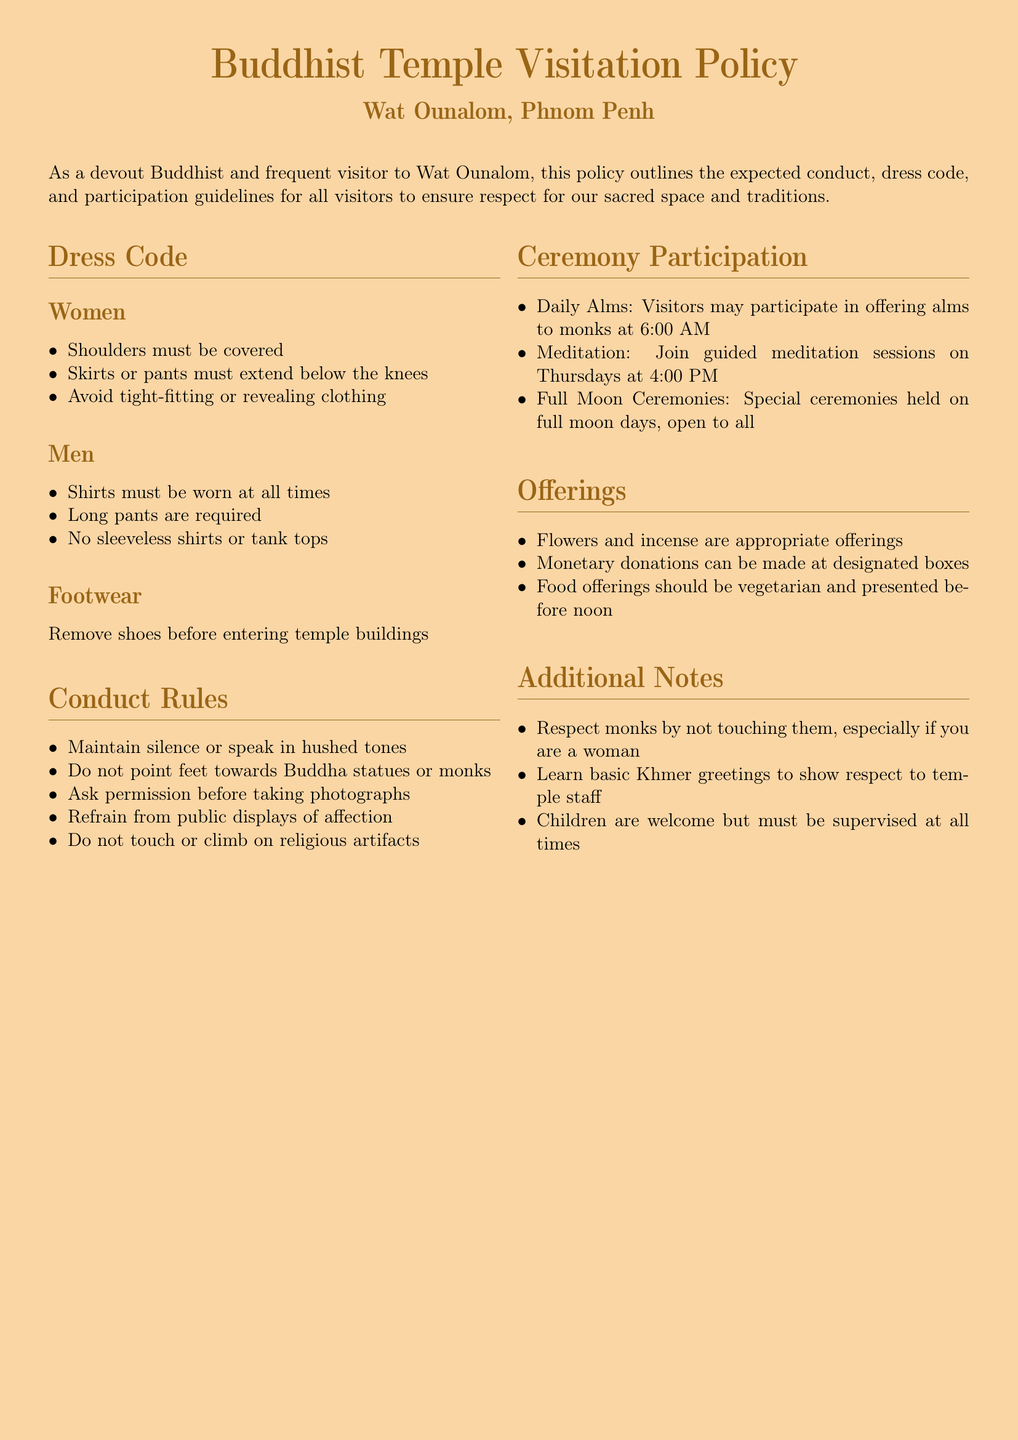what is the name of the temple? The name of the temple mentioned in the document is Wat Ounalom.
Answer: Wat Ounalom what time does the daily alms begin? The document states that daily alms take place at 6:00 AM.
Answer: 6:00 AM what should women wear to the temple? The dress code section specifies that women should cover their shoulders and wear skirts or pants that extend below the knees.
Answer: Shoulders must be covered, skirts or pants must extend below the knees how should visitors behave in the temple? Visitors are expected to maintain silence or speak in hushed tones as part of the conduct rules.
Answer: Maintain silence or speak in hushed tones are children allowed in the temple? The additional notes indicate that children are welcome but must be supervised at all times.
Answer: Yes, but must be supervised at all times what type of offerings are appropriate? The offerings section lists flowers, incense, and vegetarian food before noon as appropriate.
Answer: Flowers and incense, vegetarian food before noon what is the dress code for men? According to the dress code section, men must wear shirts and long pants, with no sleeveless shirts or tank tops allowed.
Answer: Shirts must be worn, long pants are required, no sleeveless shirts or tank tops when are guided meditation sessions held? The document specifies that guided meditation sessions are held on Thursdays at 4:00 PM.
Answer: Thursdays at 4:00 PM 